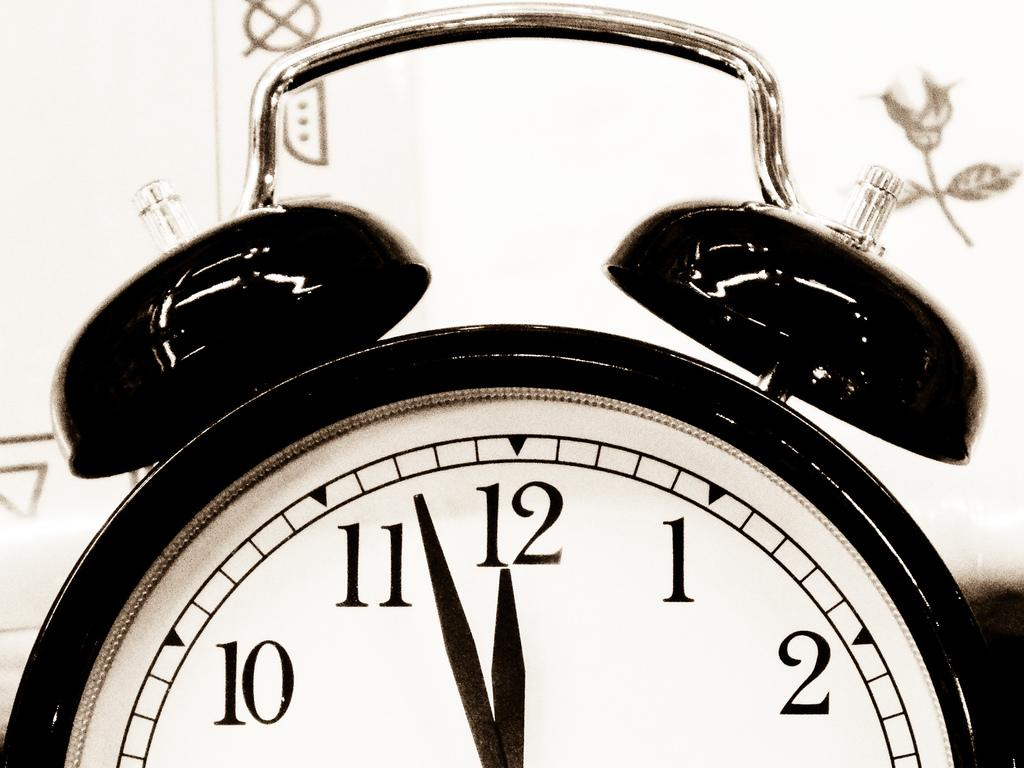<image>
Write a terse but informative summary of the picture. An analog alarm clock with only the numbers 10, 11, 12, 1, and 2 visible 